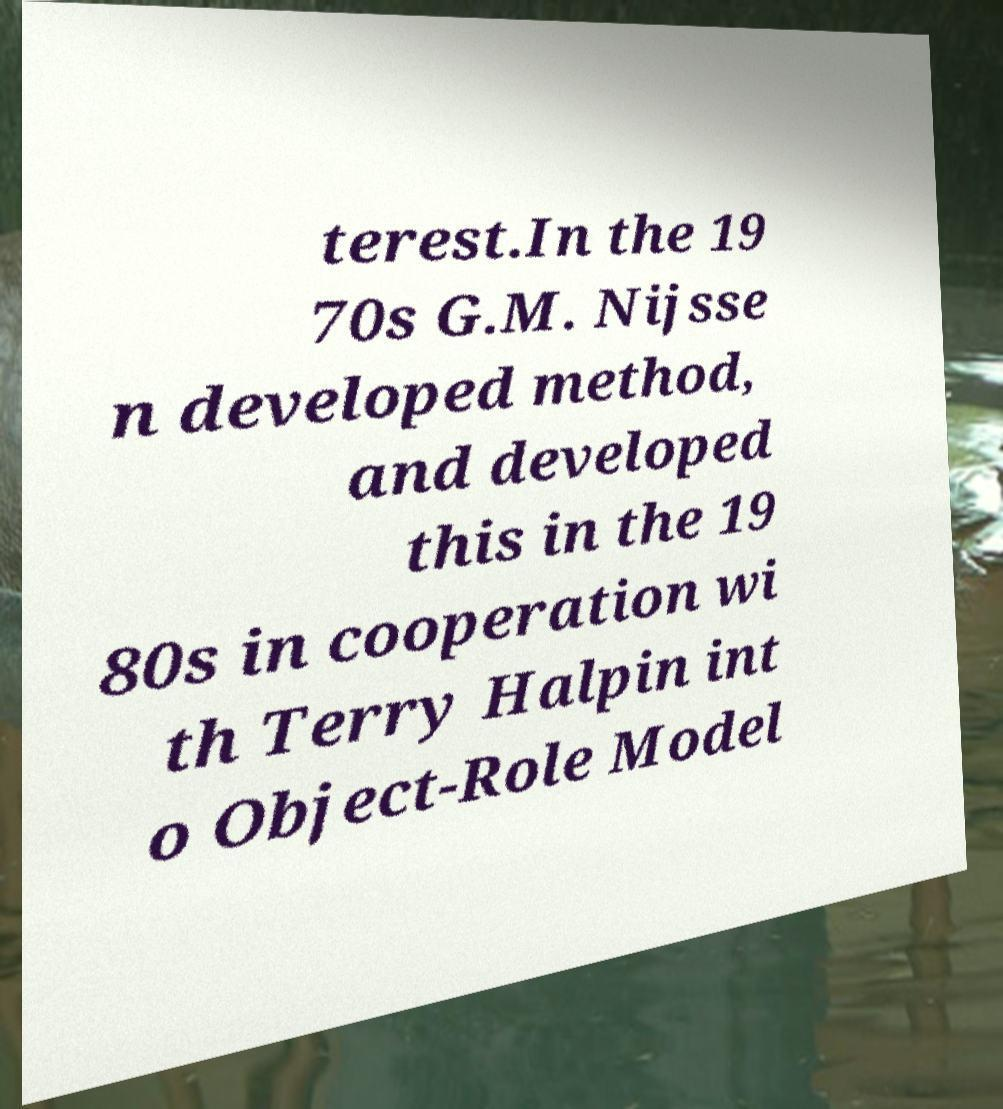Can you read and provide the text displayed in the image?This photo seems to have some interesting text. Can you extract and type it out for me? terest.In the 19 70s G.M. Nijsse n developed method, and developed this in the 19 80s in cooperation wi th Terry Halpin int o Object-Role Model 